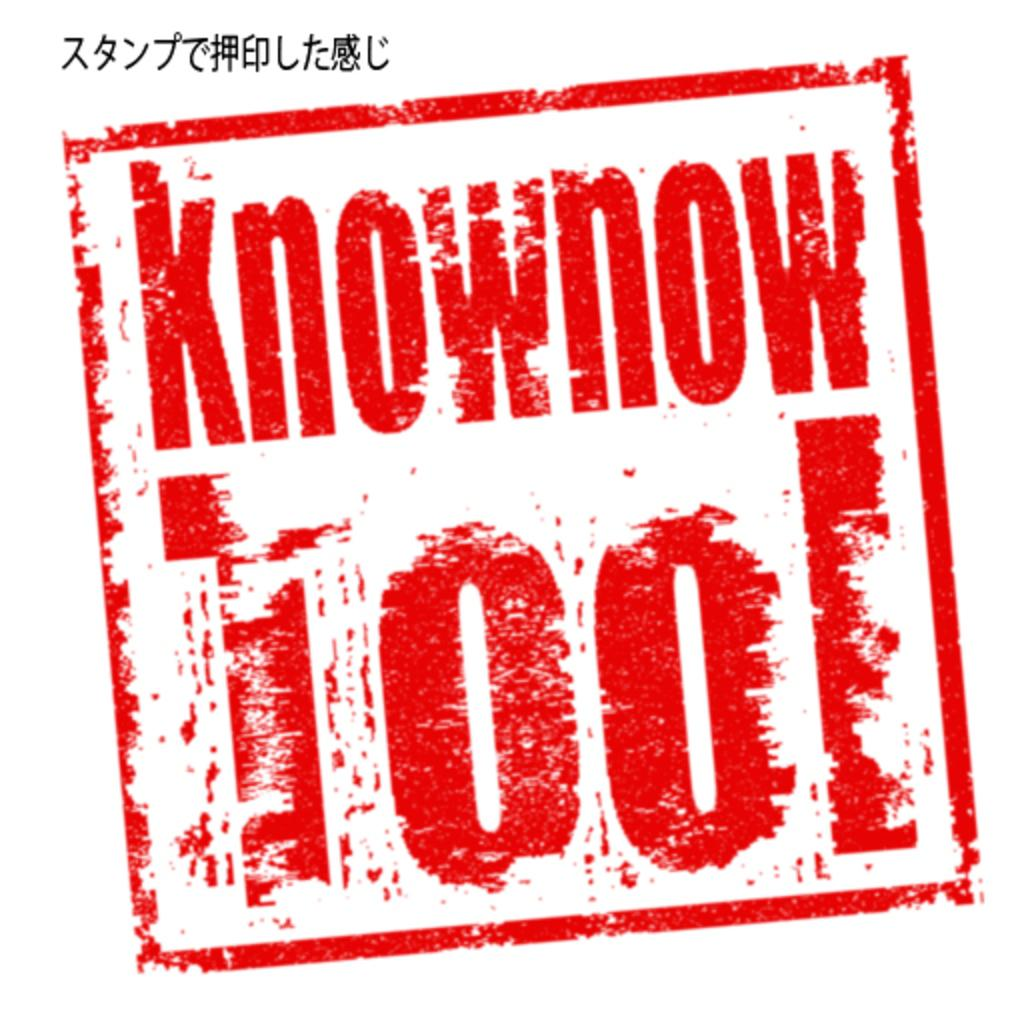What colors are used for the text in the image? The text in the image is written in red and black colors. What is the background color of the image? The background of the image is white. What type of quilt is being used to cover the text in the image? There is no quilt present in the image; it only contains text written in red and black colors on a white background. 